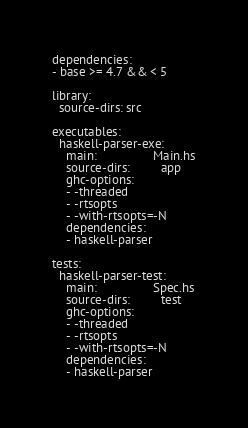<code> <loc_0><loc_0><loc_500><loc_500><_YAML_>
dependencies:
- base >= 4.7 && < 5

library:
  source-dirs: src

executables:
  haskell-parser-exe:
    main:                Main.hs
    source-dirs:         app
    ghc-options:
    - -threaded
    - -rtsopts
    - -with-rtsopts=-N
    dependencies:
    - haskell-parser

tests:
  haskell-parser-test:
    main:                Spec.hs
    source-dirs:         test
    ghc-options:
    - -threaded
    - -rtsopts
    - -with-rtsopts=-N
    dependencies:
    - haskell-parser
</code> 